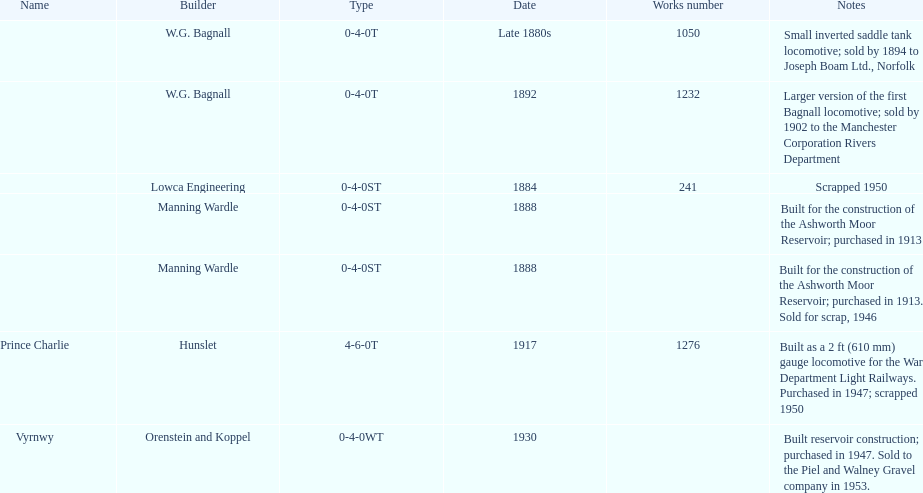List each of the builder's that had a locomotive scrapped. Lowca Engineering, Manning Wardle, Hunslet. 